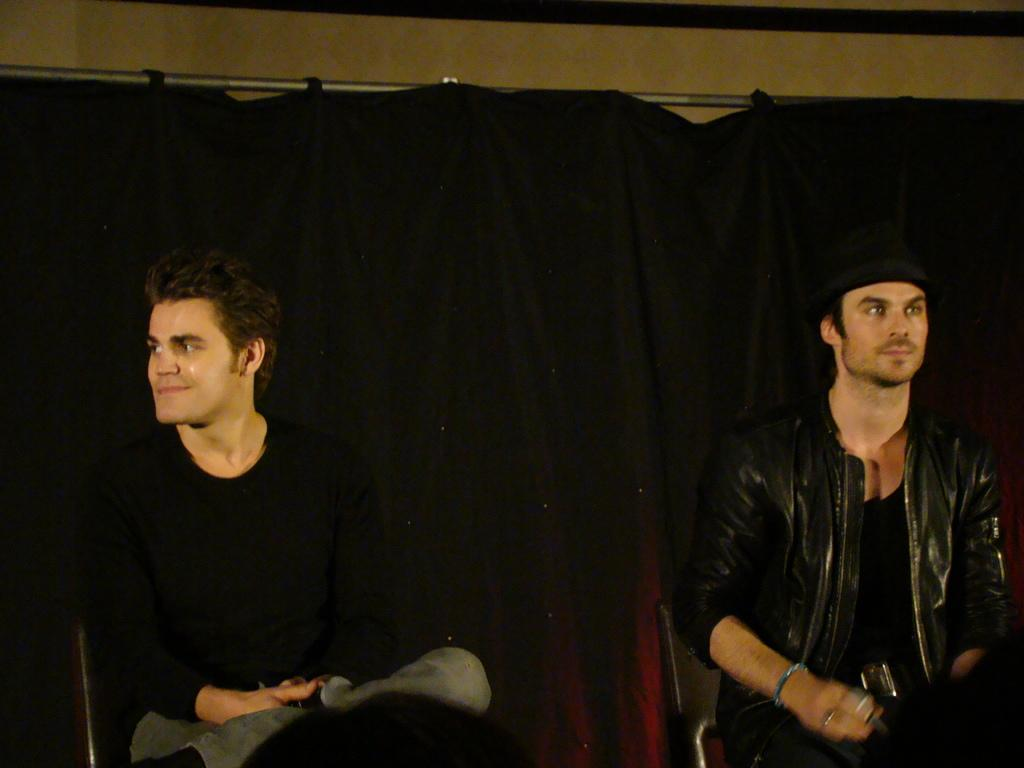How many people are in the image? There are two men in the image. What are the men wearing? The men are wearing black dress. What are the men doing in the image? The men are sitting on chairs. What can be seen on the wall behind the men? There is a curtain on the wall behind the men. What type of pear is being served to the committee in the image? There is no pear or committee present in the image. 